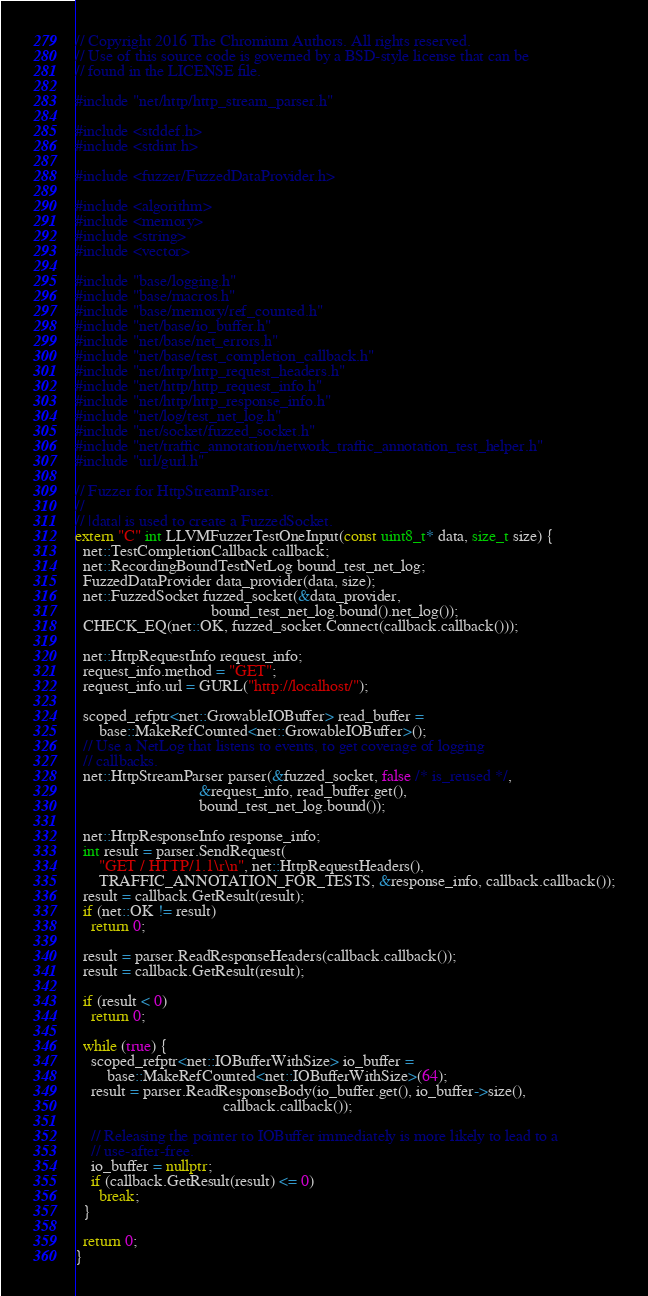Convert code to text. <code><loc_0><loc_0><loc_500><loc_500><_C++_>// Copyright 2016 The Chromium Authors. All rights reserved.
// Use of this source code is governed by a BSD-style license that can be
// found in the LICENSE file.

#include "net/http/http_stream_parser.h"

#include <stddef.h>
#include <stdint.h>

#include <fuzzer/FuzzedDataProvider.h>

#include <algorithm>
#include <memory>
#include <string>
#include <vector>

#include "base/logging.h"
#include "base/macros.h"
#include "base/memory/ref_counted.h"
#include "net/base/io_buffer.h"
#include "net/base/net_errors.h"
#include "net/base/test_completion_callback.h"
#include "net/http/http_request_headers.h"
#include "net/http/http_request_info.h"
#include "net/http/http_response_info.h"
#include "net/log/test_net_log.h"
#include "net/socket/fuzzed_socket.h"
#include "net/traffic_annotation/network_traffic_annotation_test_helper.h"
#include "url/gurl.h"

// Fuzzer for HttpStreamParser.
//
// |data| is used to create a FuzzedSocket.
extern "C" int LLVMFuzzerTestOneInput(const uint8_t* data, size_t size) {
  net::TestCompletionCallback callback;
  net::RecordingBoundTestNetLog bound_test_net_log;
  FuzzedDataProvider data_provider(data, size);
  net::FuzzedSocket fuzzed_socket(&data_provider,
                                  bound_test_net_log.bound().net_log());
  CHECK_EQ(net::OK, fuzzed_socket.Connect(callback.callback()));

  net::HttpRequestInfo request_info;
  request_info.method = "GET";
  request_info.url = GURL("http://localhost/");

  scoped_refptr<net::GrowableIOBuffer> read_buffer =
      base::MakeRefCounted<net::GrowableIOBuffer>();
  // Use a NetLog that listens to events, to get coverage of logging
  // callbacks.
  net::HttpStreamParser parser(&fuzzed_socket, false /* is_reused */,
                               &request_info, read_buffer.get(),
                               bound_test_net_log.bound());

  net::HttpResponseInfo response_info;
  int result = parser.SendRequest(
      "GET / HTTP/1.1\r\n", net::HttpRequestHeaders(),
      TRAFFIC_ANNOTATION_FOR_TESTS, &response_info, callback.callback());
  result = callback.GetResult(result);
  if (net::OK != result)
    return 0;

  result = parser.ReadResponseHeaders(callback.callback());
  result = callback.GetResult(result);

  if (result < 0)
    return 0;

  while (true) {
    scoped_refptr<net::IOBufferWithSize> io_buffer =
        base::MakeRefCounted<net::IOBufferWithSize>(64);
    result = parser.ReadResponseBody(io_buffer.get(), io_buffer->size(),
                                     callback.callback());

    // Releasing the pointer to IOBuffer immediately is more likely to lead to a
    // use-after-free.
    io_buffer = nullptr;
    if (callback.GetResult(result) <= 0)
      break;
  }

  return 0;
}
</code> 